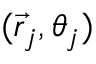<formula> <loc_0><loc_0><loc_500><loc_500>( \vec { r } _ { j } , \theta _ { j } )</formula> 